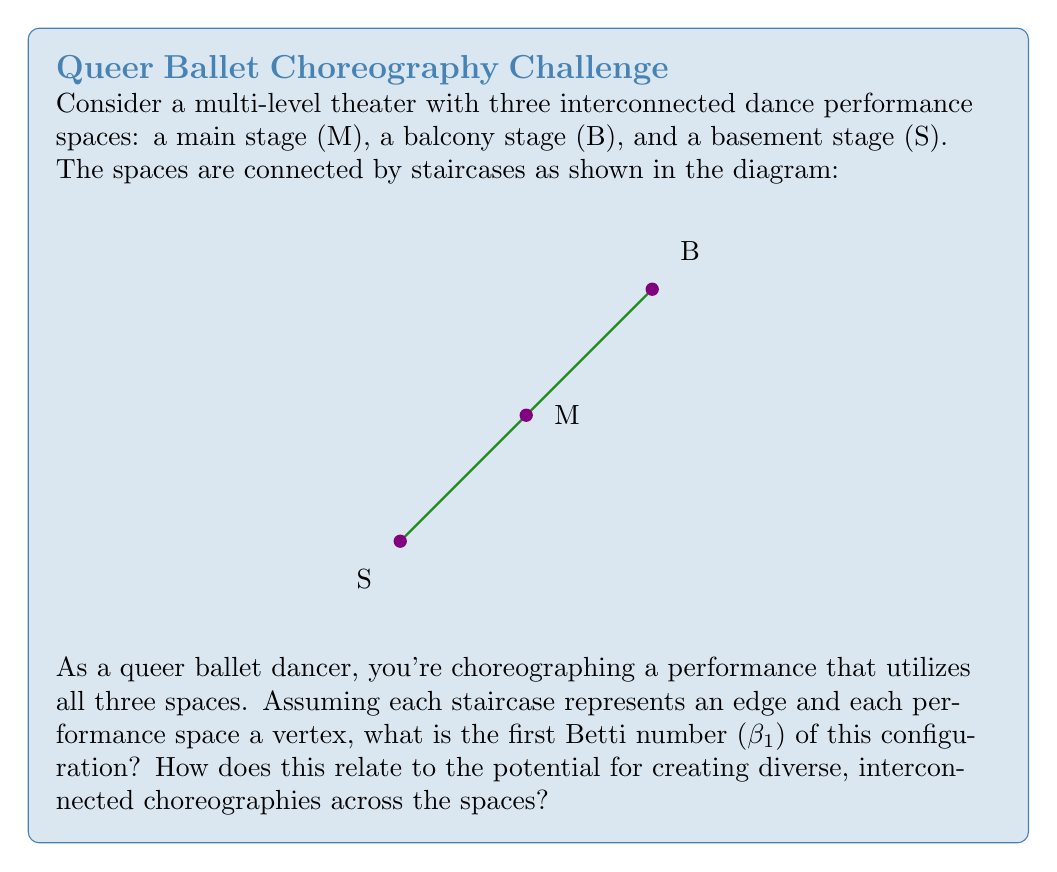Give your solution to this math problem. To solve this problem, we'll follow these steps:

1) First, let's understand what the first Betti number (β₁) represents. In topology, β₁ is the rank of the first homology group, which intuitively represents the number of 1-dimensional holes or loops in the space.

2) In graph theory, for a connected graph, β₁ can be calculated using the formula:

   $$β₁ = E - V + 1$$

   where E is the number of edges and V is the number of vertices.

3) In our configuration:
   - Number of vertices (V) = 3 (M, B, and S)
   - Number of edges (E) = 3 (the staircases connecting the spaces)

4) Plugging these values into the formula:

   $$β₁ = 3 - 3 + 1 = 1$$

5) This means there is one 1-dimensional hole or loop in the configuration.

6) In terms of choreography, this topology allows for:
   - Continuous flow between all spaces (you can move from any space to any other without retracing steps)
   - The ability to create circular patterns in the overall performance
   - Opportunities for parallel performances or contrasting themes in different spaces that can interweave

7) The non-zero β₁ indicates a level of complexity that can be leveraged for creative, diverse choreographies, potentially symbolizing the interconnectedness of different identities or experiences in queer representation.
Answer: β₁ = 1 